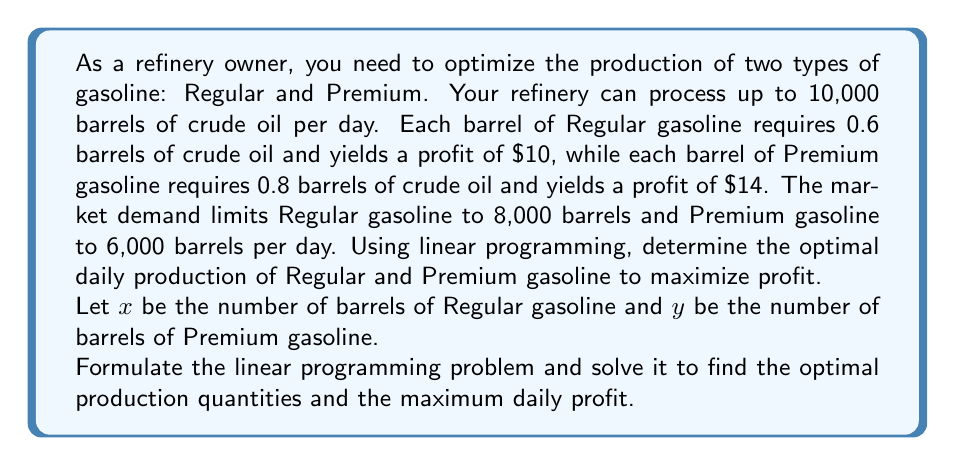Solve this math problem. To solve this linear programming problem, we need to follow these steps:

1. Define the objective function
2. Identify the constraints
3. Graph the feasible region
4. Find the optimal solution

1. Objective function:
Maximize profit: $P = 10x + 14y$

2. Constraints:
a) Crude oil limitation: $0.6x + 0.8y \leq 10000$
b) Regular gasoline demand: $x \leq 8000$
c) Premium gasoline demand: $y \leq 6000$
d) Non-negativity: $x \geq 0, y \geq 0$

3. Graph the feasible region:
[asy]
import geometry;

size(300,300);

real xmax = 10000;
real ymax = 8000;

draw((0,0)--(xmax,0)--(xmax,ymax)--(0,ymax)--cycle);

draw((0,12500)--(16667,0), blue);
draw((8000,0)--(8000,ymax), red);
draw((0,6000)--(xmax,6000), green);

label("$0.6x + 0.8y = 10000$", (8000,3000), E, blue);
label("$x = 8000$", (8000,7000), E, red);
label("$y = 6000$", (2000,6000), W, green);

dot((8000,6000));
dot((8000,2500));
dot((5000,6000));

label("A (8000, 6000)", (8000,6000), NE);
label("B (8000, 2500)", (8000,2500), SE);
label("C (5000, 6000)", (5000,6000), NW);

[/asy]

4. Find the optimal solution:
The optimal solution will be at one of the corner points of the feasible region. We need to evaluate the objective function at each of these points:

Point A (8000, 6000): $P = 10(8000) + 14(6000) = 164,000$
Point B (8000, 2500): $P = 10(8000) + 14(2500) = 115,000$
Point C (5000, 6000): $P = 10(5000) + 14(6000) = 134,000$

The maximum profit occurs at point A (8000, 6000).
Answer: The optimal daily production is 8,000 barrels of Regular gasoline and 6,000 barrels of Premium gasoline, yielding a maximum daily profit of $164,000. 